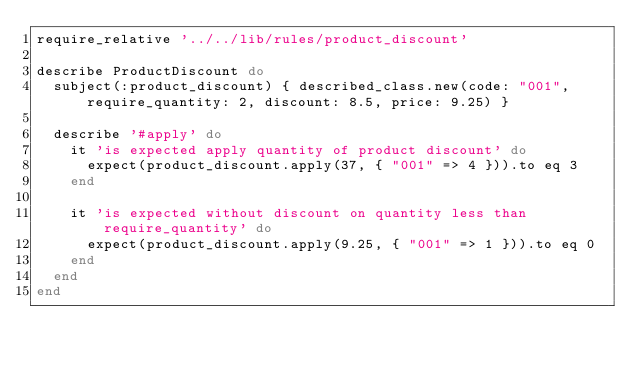<code> <loc_0><loc_0><loc_500><loc_500><_Ruby_>require_relative '../../lib/rules/product_discount'

describe ProductDiscount do
  subject(:product_discount) { described_class.new(code: "001", require_quantity: 2, discount: 8.5, price: 9.25) }

  describe '#apply' do
    it 'is expected apply quantity of product discount' do
      expect(product_discount.apply(37, { "001" => 4 })).to eq 3
    end

    it 'is expected without discount on quantity less than require_quantity' do
      expect(product_discount.apply(9.25, { "001" => 1 })).to eq 0
    end
  end
end</code> 